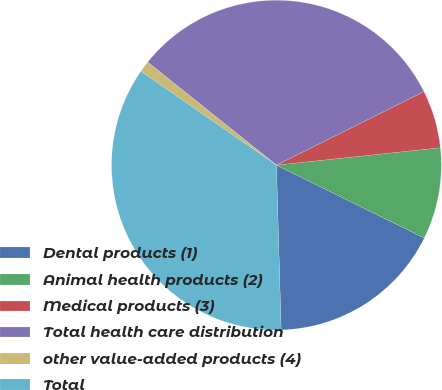Convert chart to OTSL. <chart><loc_0><loc_0><loc_500><loc_500><pie_chart><fcel>Dental products (1)<fcel>Animal health products (2)<fcel>Medical products (3)<fcel>Total health care distribution<fcel>other value-added products (4)<fcel>Total<nl><fcel>17.26%<fcel>8.97%<fcel>5.68%<fcel>31.91%<fcel>1.09%<fcel>35.1%<nl></chart> 